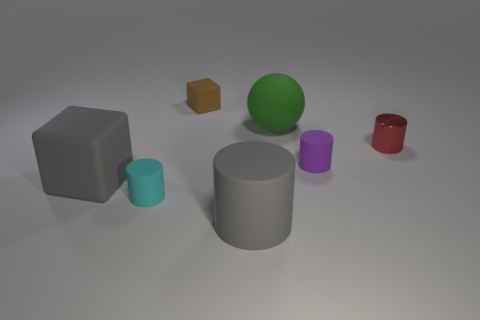Is there any other thing that is the same shape as the big green thing?
Offer a terse response. No. Is there any other thing that has the same size as the cyan thing?
Your answer should be compact. Yes. Are there more big matte cubes than big cyan rubber cubes?
Your answer should be compact. Yes. How big is the thing that is both behind the tiny cyan cylinder and left of the brown matte thing?
Give a very brief answer. Large. The small red metallic object has what shape?
Provide a short and direct response. Cylinder. How many other tiny metal objects are the same shape as the red metal object?
Give a very brief answer. 0. Is the number of small blocks that are on the left side of the red cylinder less than the number of tiny rubber things to the right of the green matte object?
Your answer should be compact. No. There is a cylinder to the right of the tiny purple rubber thing; how many objects are on the left side of it?
Give a very brief answer. 6. Are there any tiny cylinders?
Provide a short and direct response. Yes. Is there a brown block that has the same material as the small red thing?
Ensure brevity in your answer.  No. 